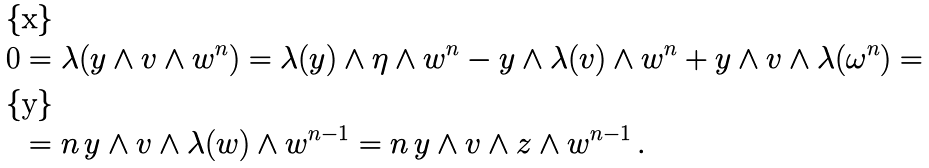<formula> <loc_0><loc_0><loc_500><loc_500>0 & = \lambda ( y \wedge v \wedge w ^ { n } ) = \lambda ( y ) \wedge \eta \wedge w ^ { n } - y \wedge \lambda ( v ) \wedge w ^ { n } + y \wedge v \wedge \lambda ( \omega ^ { n } ) = \\ & = n \, y \wedge v \wedge \lambda ( w ) \wedge w ^ { n - 1 } = n \, y \wedge v \wedge z \wedge w ^ { n - 1 } \, .</formula> 